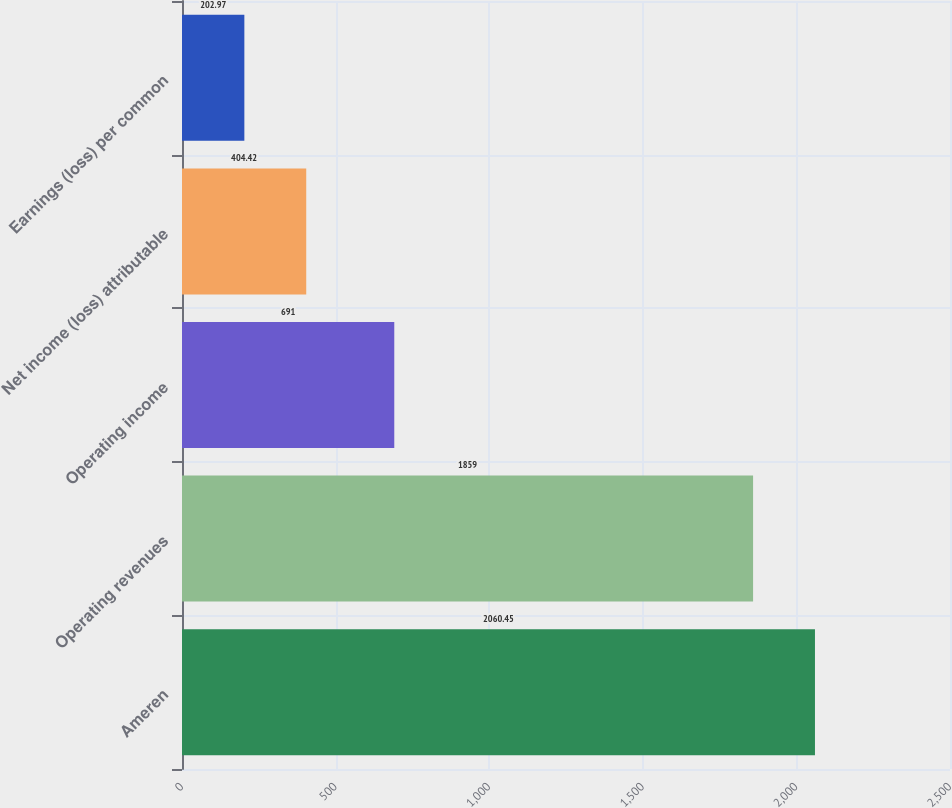<chart> <loc_0><loc_0><loc_500><loc_500><bar_chart><fcel>Ameren<fcel>Operating revenues<fcel>Operating income<fcel>Net income (loss) attributable<fcel>Earnings (loss) per common<nl><fcel>2060.45<fcel>1859<fcel>691<fcel>404.42<fcel>202.97<nl></chart> 